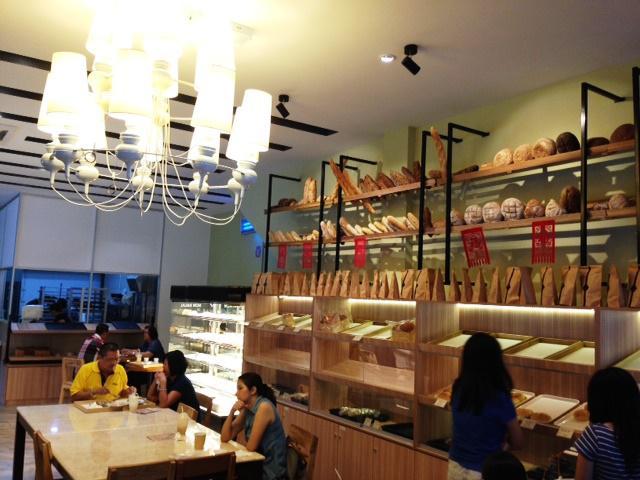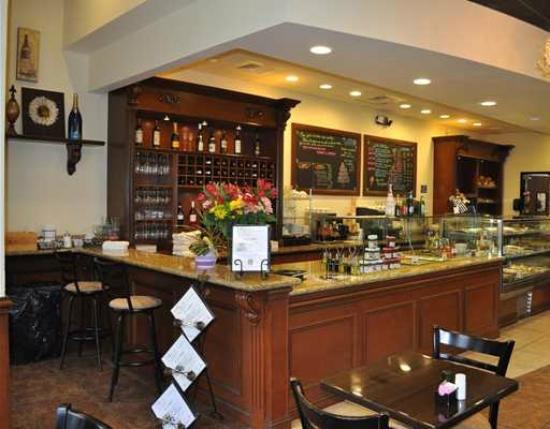The first image is the image on the left, the second image is the image on the right. Given the left and right images, does the statement "At least one person is standing at a counter and at least one person is sitting at a table with wood chairs around it in one image." hold true? Answer yes or no. Yes. The first image is the image on the left, the second image is the image on the right. Assess this claim about the two images: "In at least one image there are two bright lights focused on a coffee chalkboard.". Correct or not? Answer yes or no. No. 